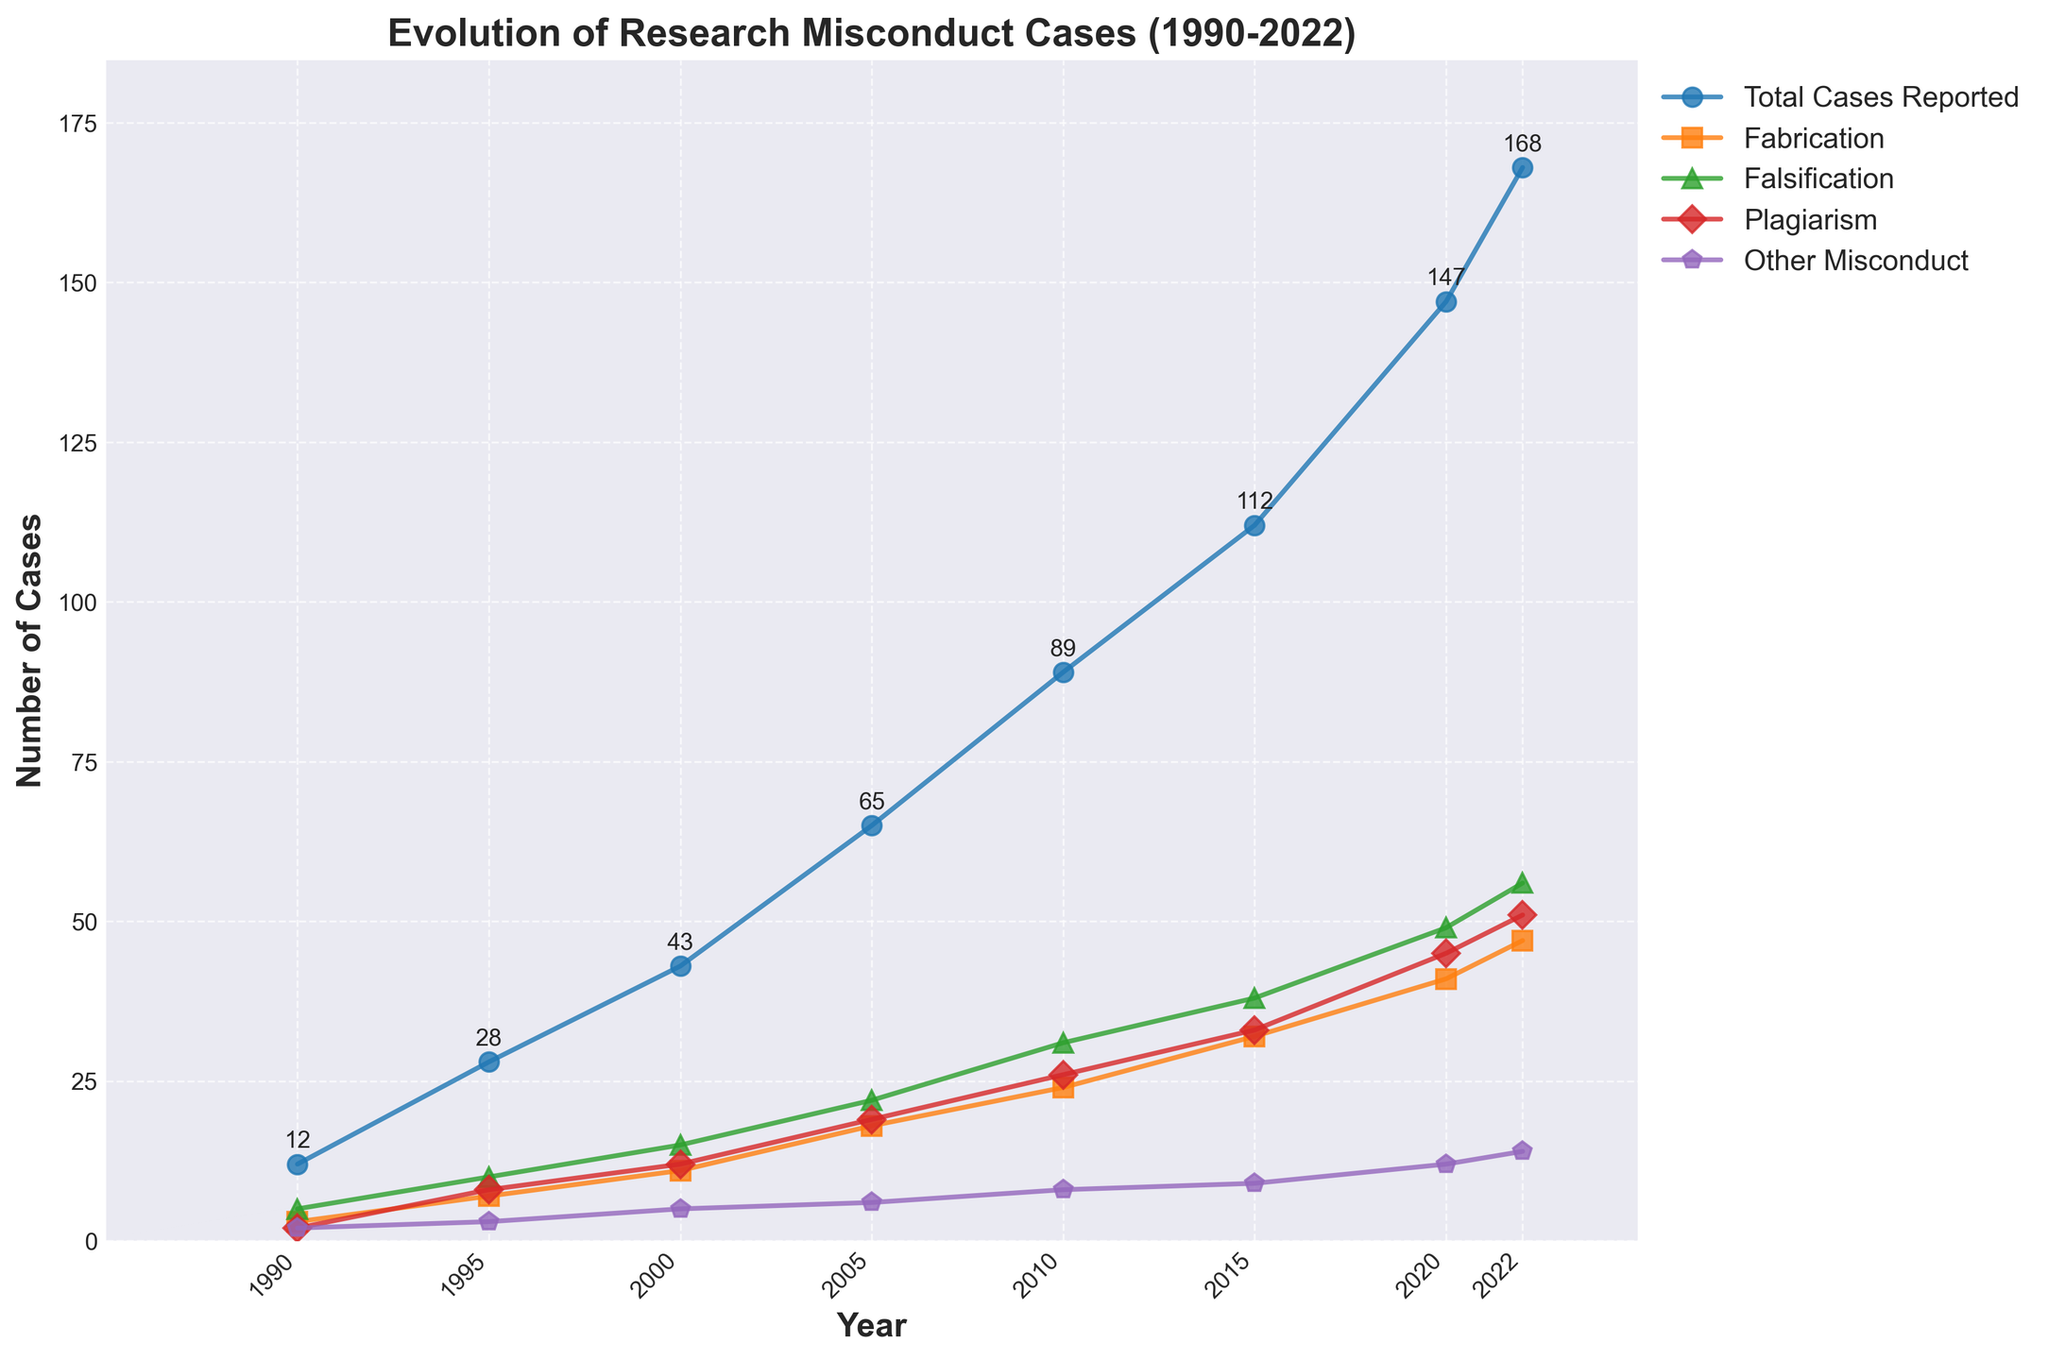What is the trend in the number of total cases reported from 1990 to 2022? The figure shows an upward trend in the number of total cases reported over the years, starting from 12 cases in 1990 to 168 cases in 2022. The trend is steadily increasing over the entire period.
Answer: Increasing trend In which year was the number of cases of plagiarism highest? From the figure, the highest number of plagiarism cases is in 2022, with 51 cases reported.
Answer: 2022 Which category of misconduct had the smallest increase in reported cases from 1990 to 2022? By examining the differences in case numbers between 1990 and 2022 for each category: Fabrication (47-3=44), Falsification (56-5=51), Plagiarism (51-2=49), Other Misconduct (14-2=12). The category "Other Misconduct" had the smallest increase (12 cases).
Answer: Other Misconduct Between which consecutive five-year periods did the total cases reported increase the most? Calculating the increase: 1990-1995 (28-12=16), 1995-2000 (43-28=15), 2000-2005 (65-43=22), 2005-2010 (89-65=24), 2010-2015 (112-89=23), 2015-2020 (147-112=35), 2020-2022 (168-147=21). The highest increase is between 2015 and 2020 (35 cases).
Answer: 2015-2020 What can be inferred about the relationship between total cases reported and falsification cases over the years? The figure shows that the number of falsification cases increases over time, and this increase is almost parallel to the trend of total cases reported, indicating a strong association between the two.
Answer: Strong association How many more cases of fabrication were there in 2022 compared to 1995? The number of fabrication cases in 2022 is 47, and in 1995 it was 7. The difference is 47 - 7 = 40 cases.
Answer: 40 cases What proportion of the total cases reported were falsification cases in 2010? In 2010, there were 89 total cases reported and 31 falsification cases. The proportion is 31/89 = 0.3483, or approximately 34.83%.
Answer: 34.83% Which category showed the most significant increase in the number of reported cases between 2005 and 2010? The increase in each category: Fabrication (24-18=6), Falsification (31-22=9), Plagiarism (26-19=7), Other Misconduct (8-6=2). Falsification shows the most significant increase (9 cases).
Answer: Falsification What is the average number of reported cases of fabrication from 1990 to 2022? Summing up the cases of fabrication: 3+7+11+18+24+32+41+47=183. There are 8 data points. The average is 183/8 = 22.875.
Answer: 22.875 Which year had the lowest number of total reported cases and how many were reported? The figure shows the lowest number of total reported cases in 1990, with 12 cases.
Answer: 1990, 12 cases 